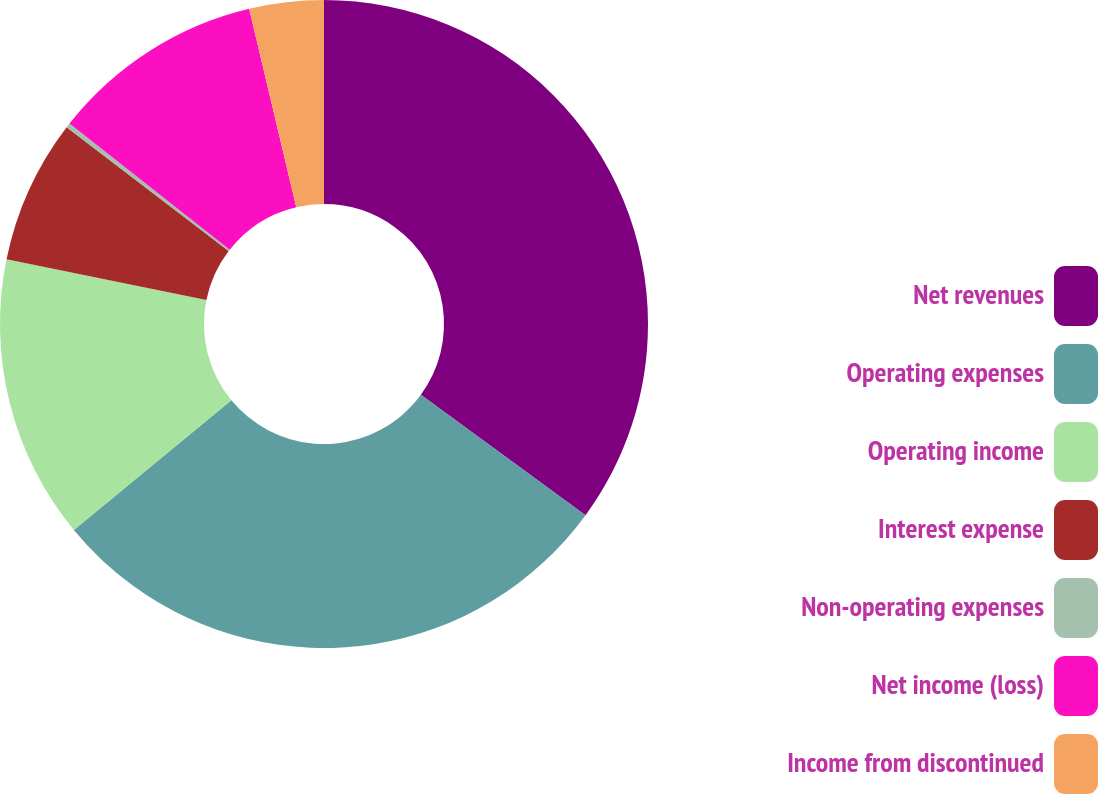Convert chart. <chart><loc_0><loc_0><loc_500><loc_500><pie_chart><fcel>Net revenues<fcel>Operating expenses<fcel>Operating income<fcel>Interest expense<fcel>Non-operating expenses<fcel>Net income (loss)<fcel>Income from discontinued<nl><fcel>35.05%<fcel>28.99%<fcel>14.16%<fcel>7.19%<fcel>0.23%<fcel>10.67%<fcel>3.71%<nl></chart> 